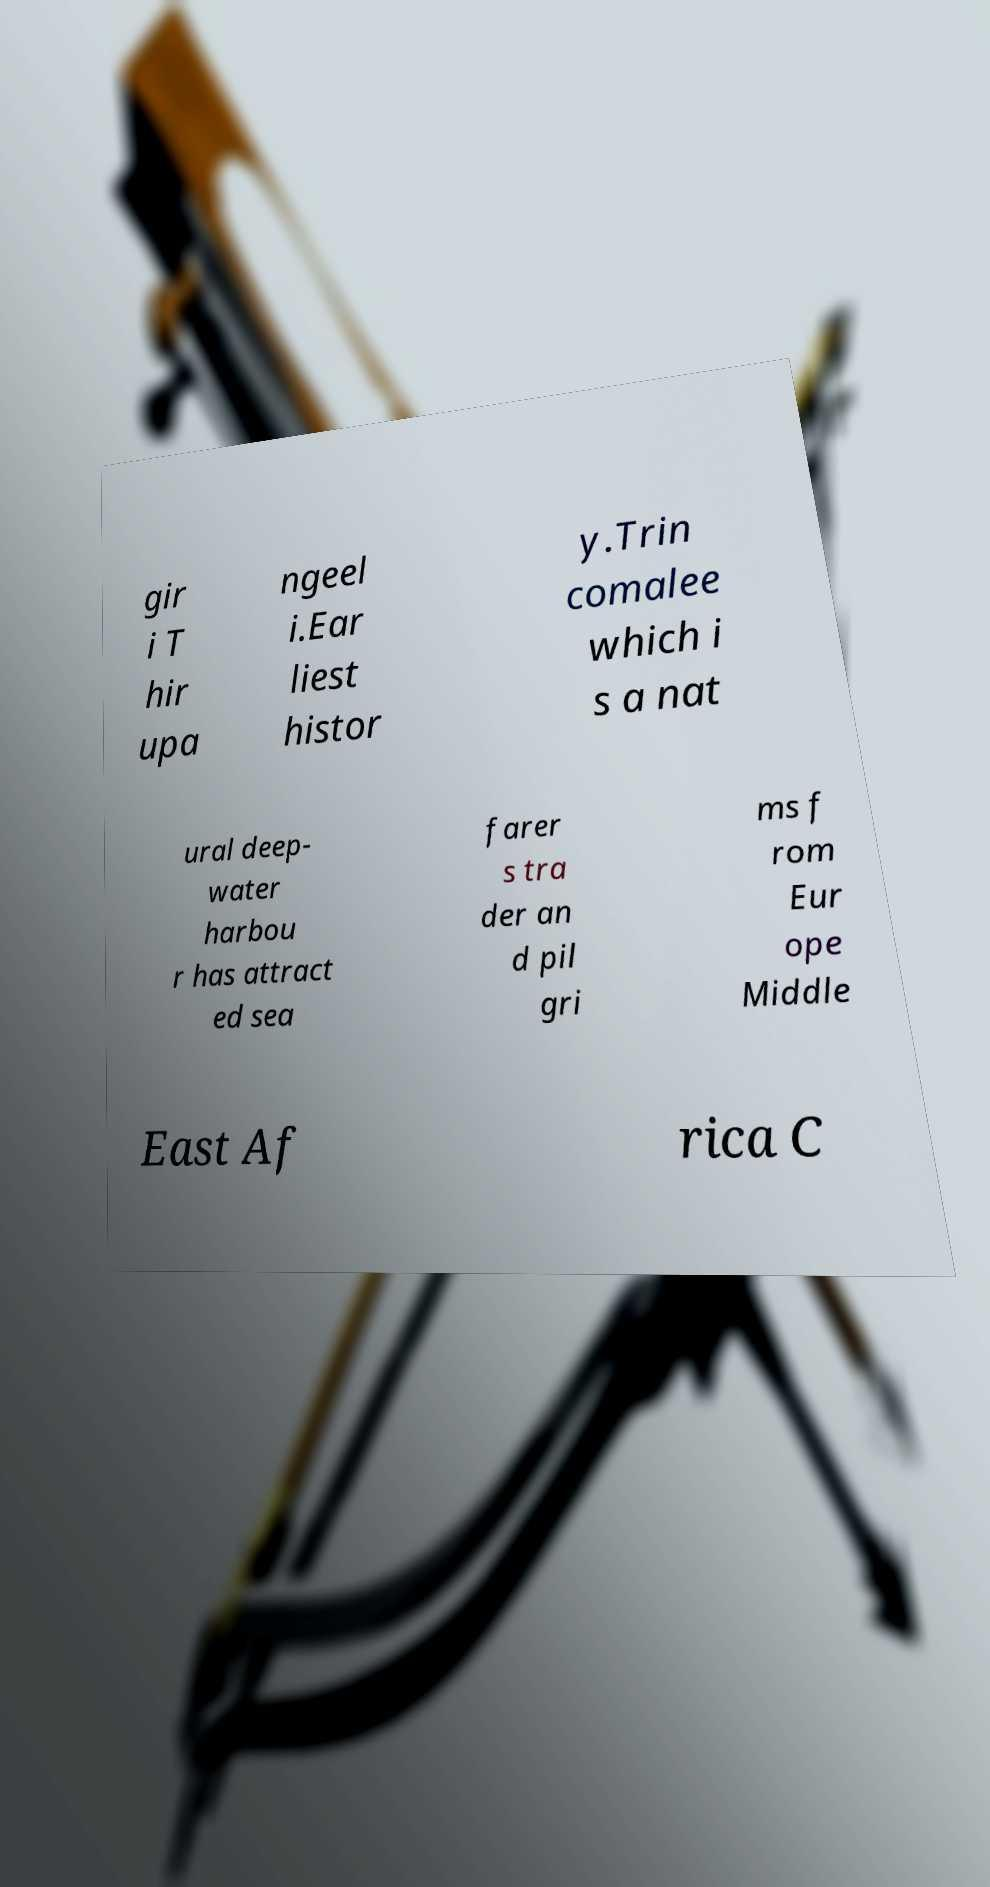Can you read and provide the text displayed in the image?This photo seems to have some interesting text. Can you extract and type it out for me? gir i T hir upa ngeel i.Ear liest histor y.Trin comalee which i s a nat ural deep- water harbou r has attract ed sea farer s tra der an d pil gri ms f rom Eur ope Middle East Af rica C 